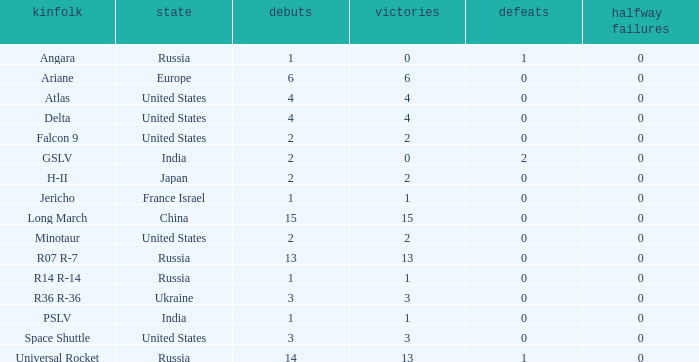What is the partial failure for the Country of russia, and a Failure larger than 0, and a Family of angara, and a Launch larger than 1? None. 